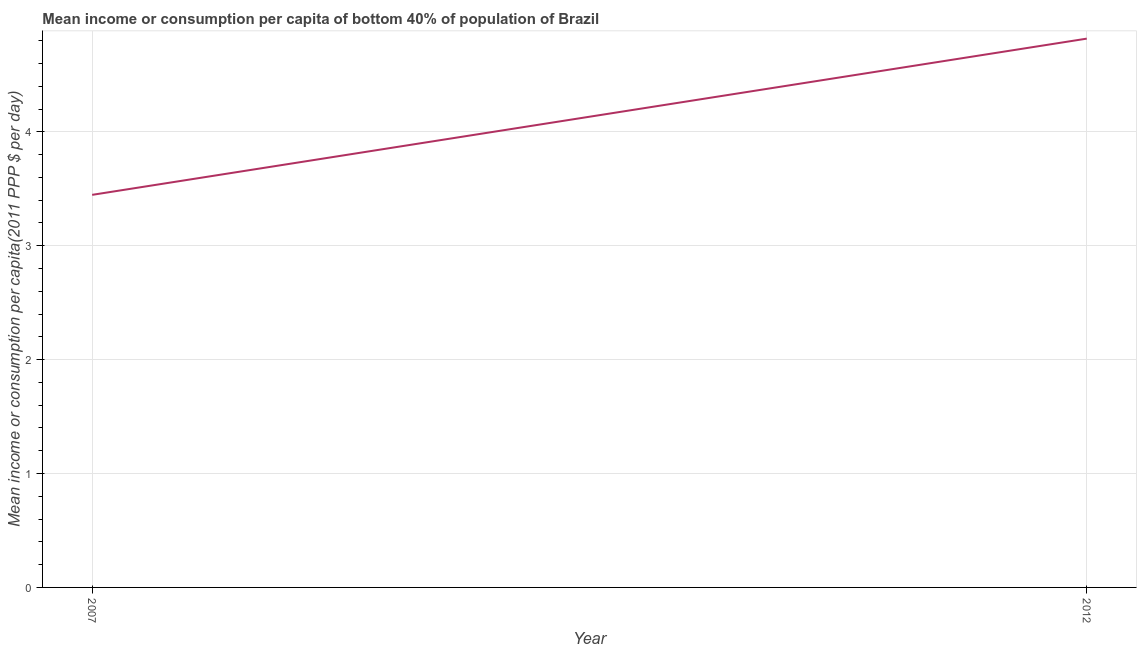What is the mean income or consumption in 2012?
Your answer should be very brief. 4.82. Across all years, what is the maximum mean income or consumption?
Provide a short and direct response. 4.82. Across all years, what is the minimum mean income or consumption?
Provide a short and direct response. 3.45. In which year was the mean income or consumption maximum?
Provide a succinct answer. 2012. What is the sum of the mean income or consumption?
Your response must be concise. 8.27. What is the difference between the mean income or consumption in 2007 and 2012?
Ensure brevity in your answer.  -1.37. What is the average mean income or consumption per year?
Provide a succinct answer. 4.13. What is the median mean income or consumption?
Make the answer very short. 4.13. Do a majority of the years between 2012 and 2007 (inclusive) have mean income or consumption greater than 1 $?
Your response must be concise. No. What is the ratio of the mean income or consumption in 2007 to that in 2012?
Ensure brevity in your answer.  0.72. In how many years, is the mean income or consumption greater than the average mean income or consumption taken over all years?
Offer a terse response. 1. What is the difference between two consecutive major ticks on the Y-axis?
Give a very brief answer. 1. Are the values on the major ticks of Y-axis written in scientific E-notation?
Offer a very short reply. No. What is the title of the graph?
Your response must be concise. Mean income or consumption per capita of bottom 40% of population of Brazil. What is the label or title of the Y-axis?
Keep it short and to the point. Mean income or consumption per capita(2011 PPP $ per day). What is the Mean income or consumption per capita(2011 PPP $ per day) in 2007?
Give a very brief answer. 3.45. What is the Mean income or consumption per capita(2011 PPP $ per day) of 2012?
Give a very brief answer. 4.82. What is the difference between the Mean income or consumption per capita(2011 PPP $ per day) in 2007 and 2012?
Offer a very short reply. -1.37. What is the ratio of the Mean income or consumption per capita(2011 PPP $ per day) in 2007 to that in 2012?
Make the answer very short. 0.71. 